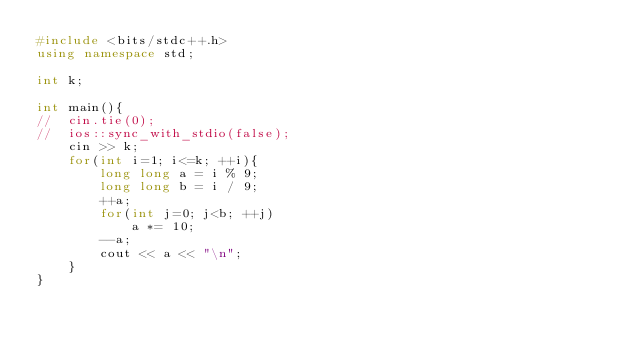<code> <loc_0><loc_0><loc_500><loc_500><_C++_>#include <bits/stdc++.h>
using namespace std;

int k;

int main(){
//	cin.tie(0);
//	ios::sync_with_stdio(false);
	cin >> k;
	for(int i=1; i<=k; ++i){
		long long a = i % 9;
		long long b = i / 9;
		++a;
		for(int j=0; j<b; ++j)
			a *= 10;
		--a;
		cout << a << "\n";
	}
}</code> 